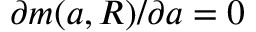<formula> <loc_0><loc_0><loc_500><loc_500>\partial m ( { a } , R ) / \partial { a } = 0</formula> 